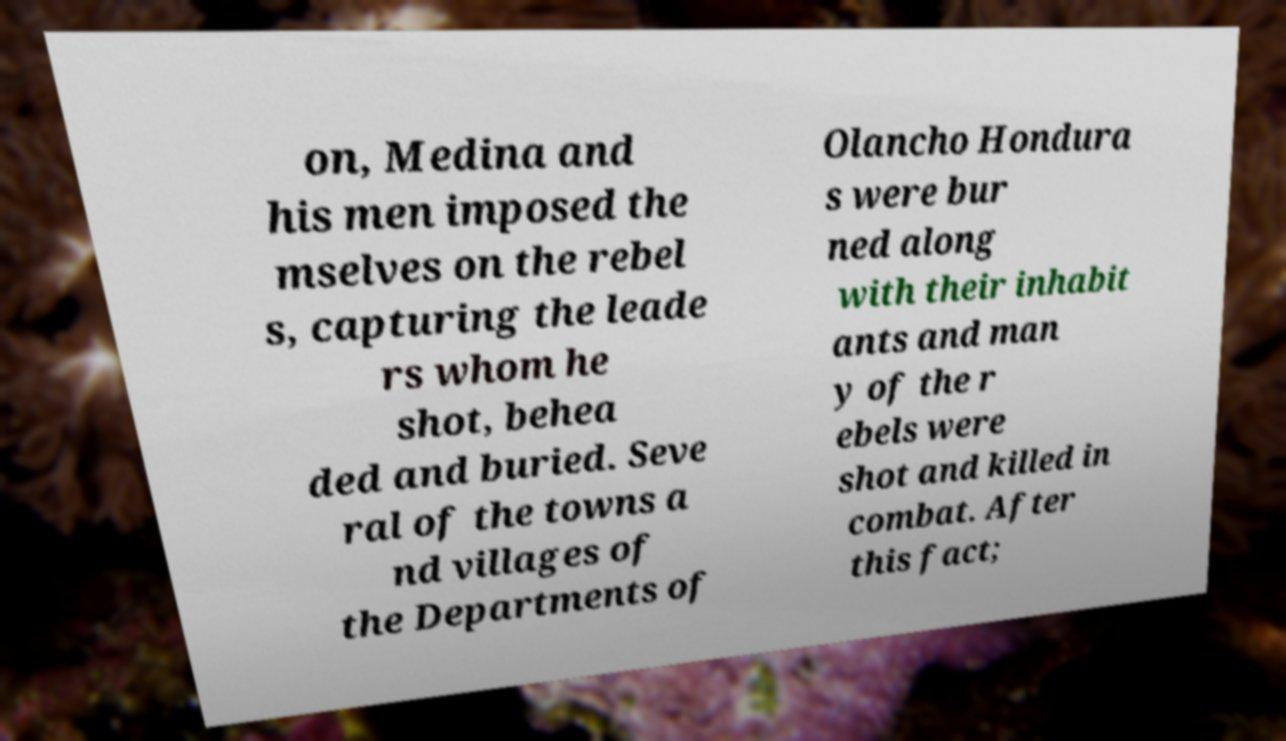There's text embedded in this image that I need extracted. Can you transcribe it verbatim? on, Medina and his men imposed the mselves on the rebel s, capturing the leade rs whom he shot, behea ded and buried. Seve ral of the towns a nd villages of the Departments of Olancho Hondura s were bur ned along with their inhabit ants and man y of the r ebels were shot and killed in combat. After this fact; 